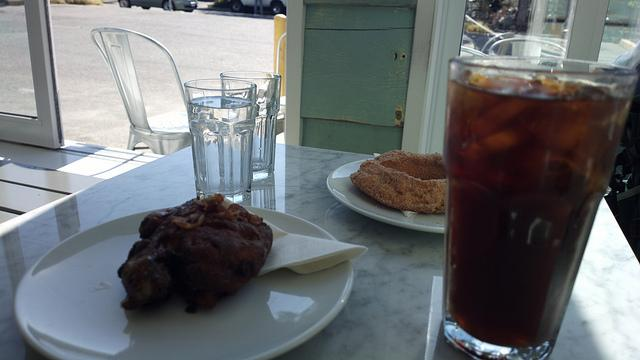Which object would have the least amount of flavors in it?

Choices:
A) donut
B) water glass
C) brown food
D) soda glass water glass 